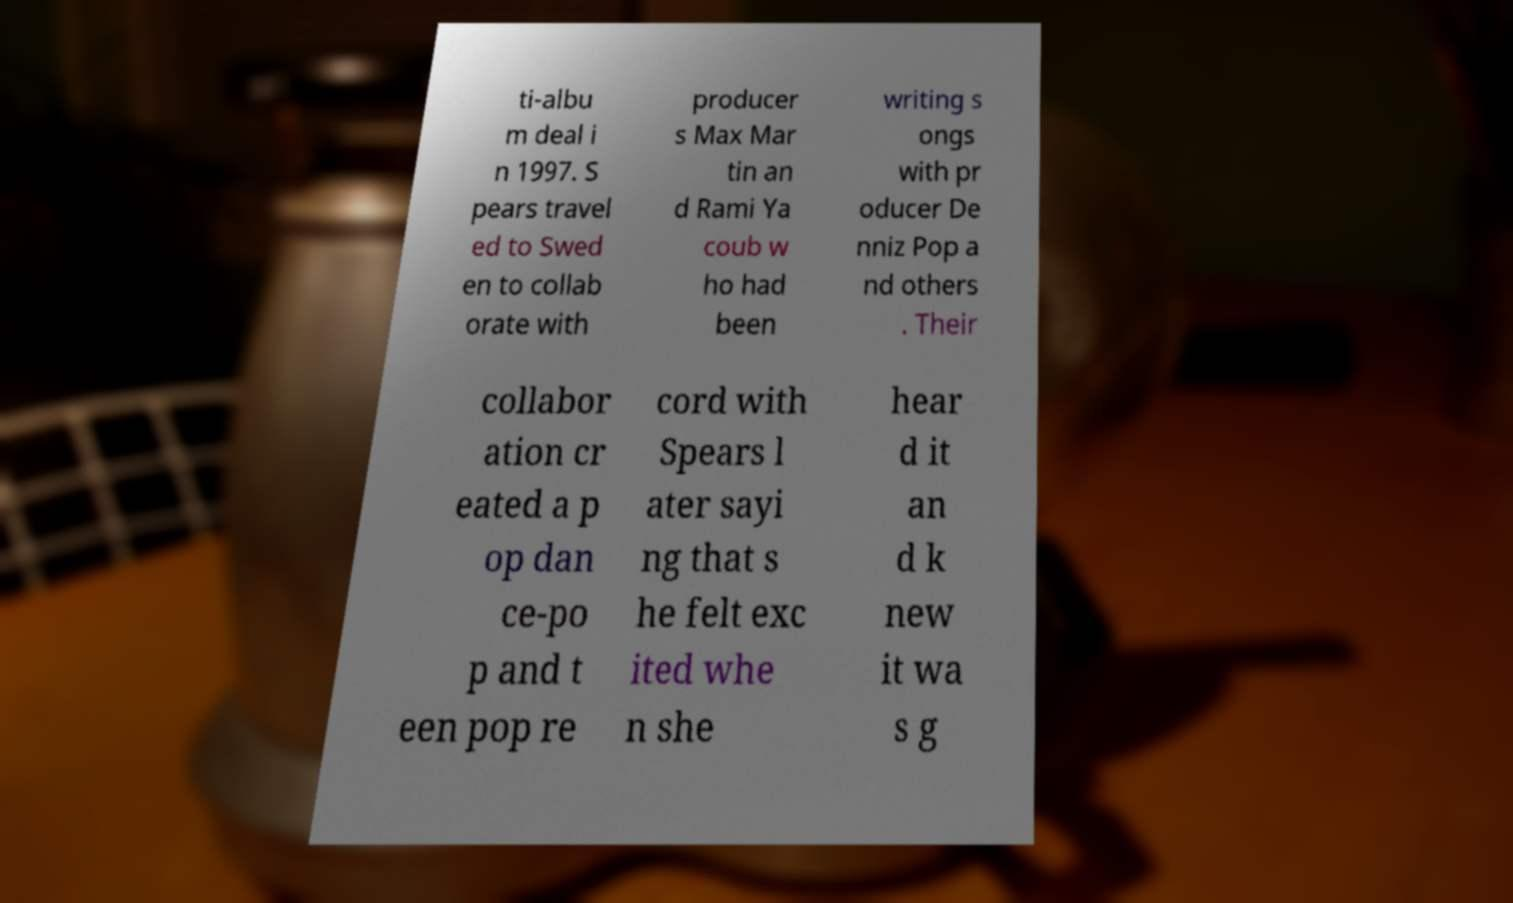What messages or text are displayed in this image? I need them in a readable, typed format. ti-albu m deal i n 1997. S pears travel ed to Swed en to collab orate with producer s Max Mar tin an d Rami Ya coub w ho had been writing s ongs with pr oducer De nniz Pop a nd others . Their collabor ation cr eated a p op dan ce-po p and t een pop re cord with Spears l ater sayi ng that s he felt exc ited whe n she hear d it an d k new it wa s g 